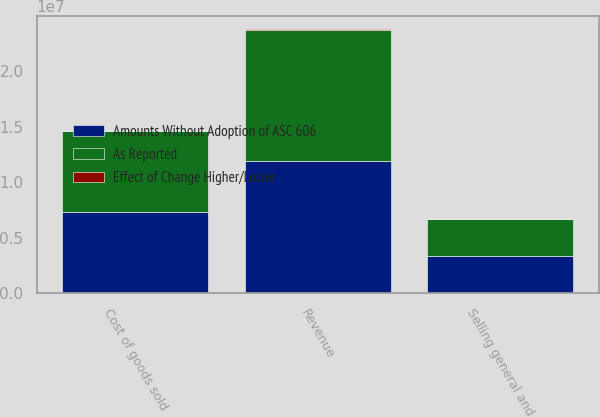<chart> <loc_0><loc_0><loc_500><loc_500><stacked_bar_chart><ecel><fcel>Revenue<fcel>Cost of goods sold<fcel>Selling general and<nl><fcel>As Reported<fcel>1.18767e+07<fcel>7.30182e+06<fcel>3.35273e+06<nl><fcel>Amounts Without Adoption of ASC 606<fcel>1.18847e+07<fcel>7.30688e+06<fcel>3.35564e+06<nl><fcel>Effect of Change Higher/Lower<fcel>7977<fcel>5068<fcel>2909<nl></chart> 